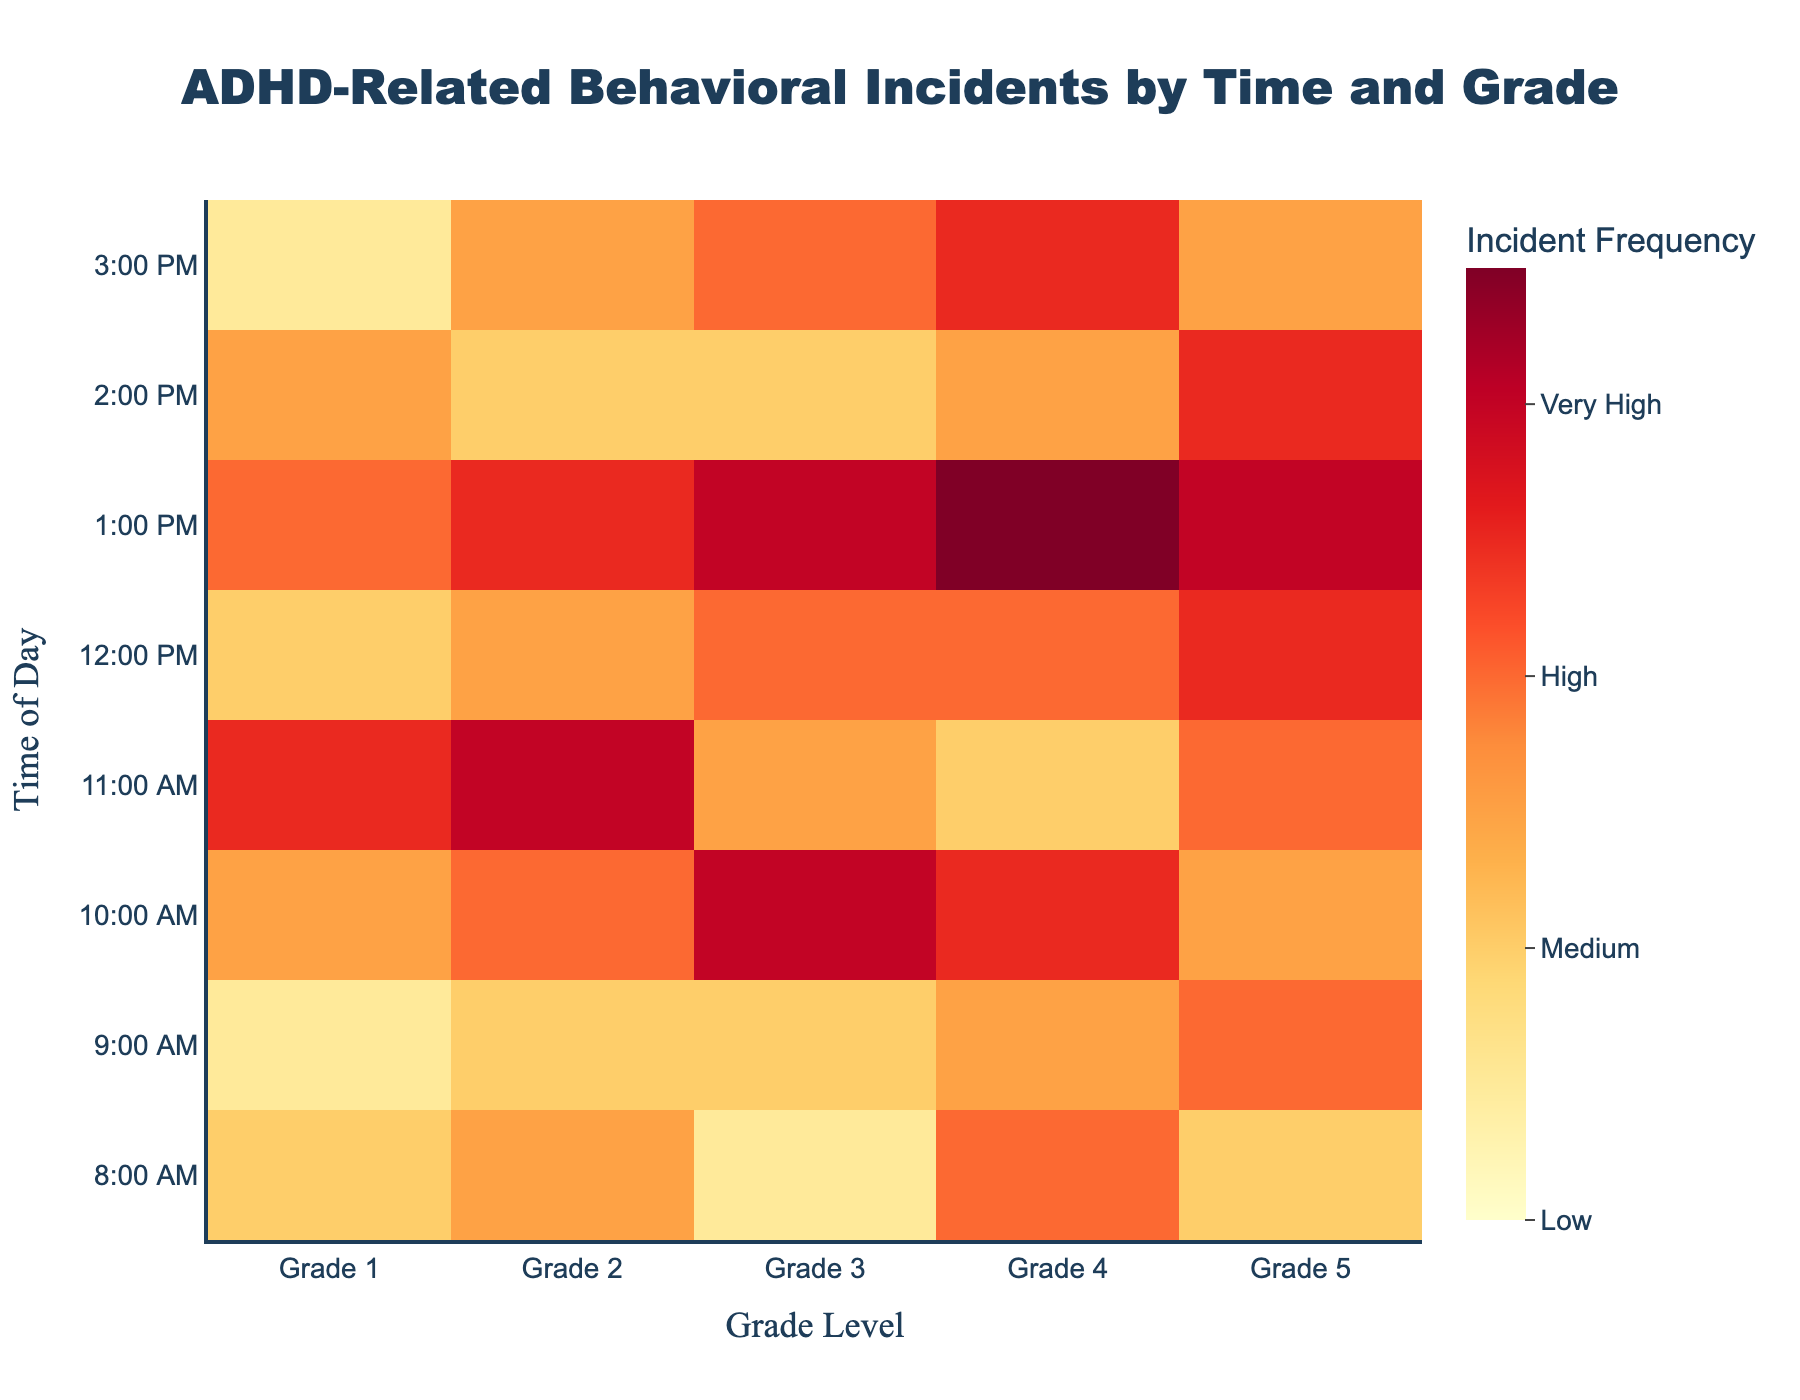What is the title of the heatmap? The title is located at the top center of the heatmap and provides an overview of the data. It reads "ADHD-Related Behavioral Incidents by Time and Grade."
Answer: ADHD-Related Behavioral Incidents by Time and Grade At what time of day does Grade 1 have the highest frequency of ADHD-related incidents? To find this, look at the row corresponding to Grade 1 and identify the time of day with the highest value. The highest value is 5, which is at 11:00 AM.
Answer: 11:00 AM Which grade and time combination has the lowest frequency of incidents? Check for the lowest value across all grades and times. The lowest value is 1, which occurs at 9:00 AM for Grade 1 and 3:00 PM for Grade 1.
Answer: 9:00 AM for Grade 1, 3:00 PM for Grade 1 What is the average frequency of incidents for Grade 5 throughout the day? Add the frequency values for Grade 5 across all times and divide by the number of times. (2+4+3+4+5+6+5+3)/8 = 4
Answer: 4 Does any grade show a consistent increase in incidents from morning to afternoon? To identify this pattern, examine if the values for any grade consistently increase from earlier to later times. Grade 4 shows an increase in incidents consistently from 8:00 AM (value 4) to 1:00 PM (value 7) before reducing.
Answer: Yes, Grade 4 until 1:00 PM Compare the frequency of incidents between Grade 3 and Grade 4 at 1:00 PM. Which one is higher? Look at the values for 1:00 PM for both Grade 3 and Grade 4. Grade 3 has 6 incidents, and Grade 4 has 7 incidents. Thus, Grade 4 is higher.
Answer: Grade 4 What is the overall trend of incident frequencies from 8:00 AM to 3:00 PM for Grade 2? Analyze the values sequentially from 8:00 AM to 3:00 PM for Grade 2. Values are: 3, 2, 4, 6, 3, 5, 2, 3. There's a peak at 11:00 AM, a dip at 12:00 PM and ending at a similar frequency as it started.
Answer: Increases to peak at 11:00 AM, then fluctuates What is the total number of incidents reported across all grades at 10:00 AM? Sum the values across all grades for 10:00 AM: 3 + 4 + 6 + 5 + 3 = 21
Answer: 21 Do any time slots have equal frequency of incidents for more than one grade? Compare frequencies across each time slot to see if any two or more grades have the same value. At 2:00 PM, both Grade 2 and Grade 3 have 2 incidents each.
Answer: 2:00 PM (Grade 2 and Grade 3) 